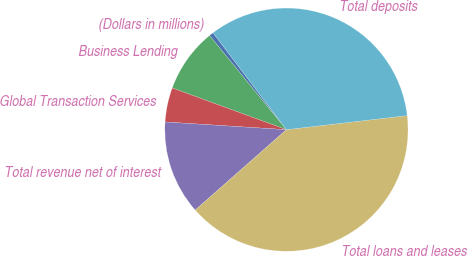Convert chart to OTSL. <chart><loc_0><loc_0><loc_500><loc_500><pie_chart><fcel>(Dollars in millions)<fcel>Business Lending<fcel>Global Transaction Services<fcel>Total revenue net of interest<fcel>Total loans and leases<fcel>Total deposits<nl><fcel>0.58%<fcel>8.53%<fcel>4.56%<fcel>12.51%<fcel>40.35%<fcel>33.47%<nl></chart> 